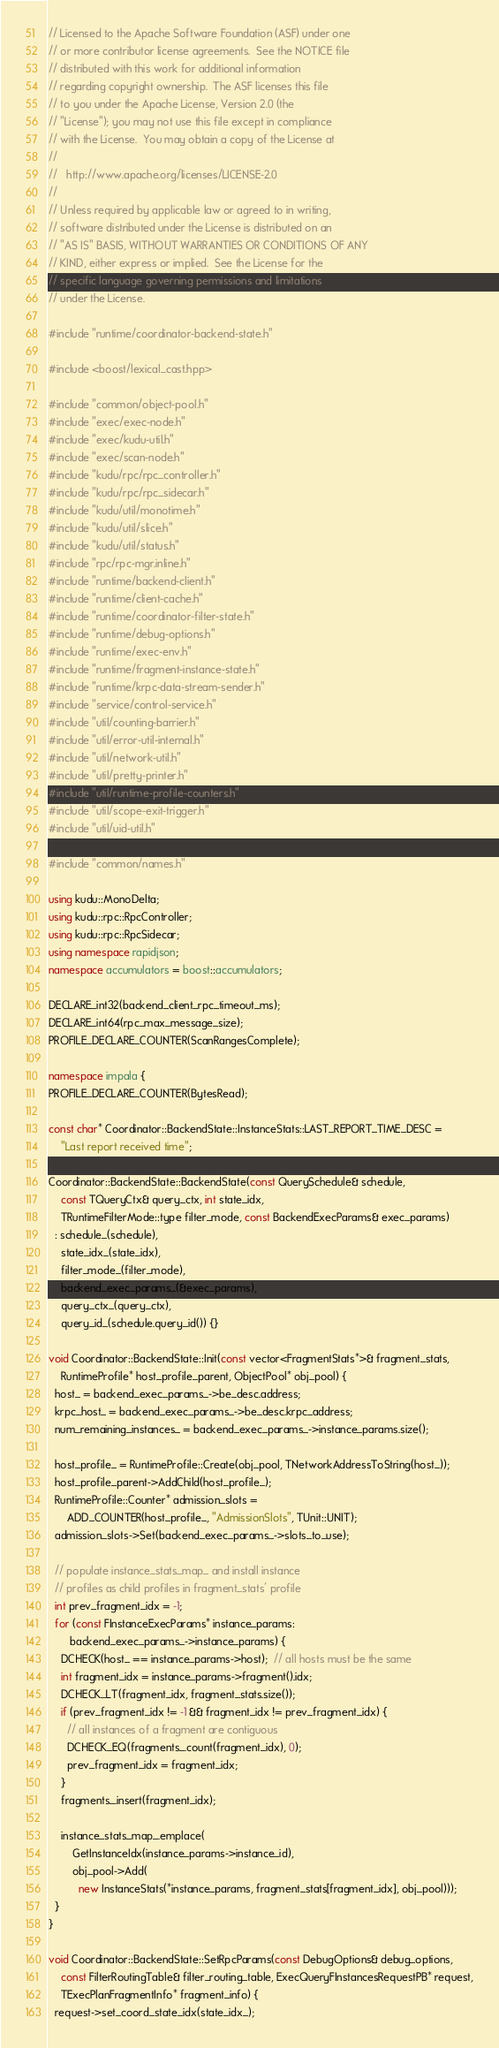Convert code to text. <code><loc_0><loc_0><loc_500><loc_500><_C++_>// Licensed to the Apache Software Foundation (ASF) under one
// or more contributor license agreements.  See the NOTICE file
// distributed with this work for additional information
// regarding copyright ownership.  The ASF licenses this file
// to you under the Apache License, Version 2.0 (the
// "License"); you may not use this file except in compliance
// with the License.  You may obtain a copy of the License at
//
//   http://www.apache.org/licenses/LICENSE-2.0
//
// Unless required by applicable law or agreed to in writing,
// software distributed under the License is distributed on an
// "AS IS" BASIS, WITHOUT WARRANTIES OR CONDITIONS OF ANY
// KIND, either express or implied.  See the License for the
// specific language governing permissions and limitations
// under the License.

#include "runtime/coordinator-backend-state.h"

#include <boost/lexical_cast.hpp>

#include "common/object-pool.h"
#include "exec/exec-node.h"
#include "exec/kudu-util.h"
#include "exec/scan-node.h"
#include "kudu/rpc/rpc_controller.h"
#include "kudu/rpc/rpc_sidecar.h"
#include "kudu/util/monotime.h"
#include "kudu/util/slice.h"
#include "kudu/util/status.h"
#include "rpc/rpc-mgr.inline.h"
#include "runtime/backend-client.h"
#include "runtime/client-cache.h"
#include "runtime/coordinator-filter-state.h"
#include "runtime/debug-options.h"
#include "runtime/exec-env.h"
#include "runtime/fragment-instance-state.h"
#include "runtime/krpc-data-stream-sender.h"
#include "service/control-service.h"
#include "util/counting-barrier.h"
#include "util/error-util-internal.h"
#include "util/network-util.h"
#include "util/pretty-printer.h"
#include "util/runtime-profile-counters.h"
#include "util/scope-exit-trigger.h"
#include "util/uid-util.h"

#include "common/names.h"

using kudu::MonoDelta;
using kudu::rpc::RpcController;
using kudu::rpc::RpcSidecar;
using namespace rapidjson;
namespace accumulators = boost::accumulators;

DECLARE_int32(backend_client_rpc_timeout_ms);
DECLARE_int64(rpc_max_message_size);
PROFILE_DECLARE_COUNTER(ScanRangesComplete);

namespace impala {
PROFILE_DECLARE_COUNTER(BytesRead);

const char* Coordinator::BackendState::InstanceStats::LAST_REPORT_TIME_DESC =
    "Last report received time";

Coordinator::BackendState::BackendState(const QuerySchedule& schedule,
    const TQueryCtx& query_ctx, int state_idx,
    TRuntimeFilterMode::type filter_mode, const BackendExecParams& exec_params)
  : schedule_(schedule),
    state_idx_(state_idx),
    filter_mode_(filter_mode),
    backend_exec_params_(&exec_params),
    query_ctx_(query_ctx),
    query_id_(schedule.query_id()) {}

void Coordinator::BackendState::Init(const vector<FragmentStats*>& fragment_stats,
    RuntimeProfile* host_profile_parent, ObjectPool* obj_pool) {
  host_ = backend_exec_params_->be_desc.address;
  krpc_host_ = backend_exec_params_->be_desc.krpc_address;
  num_remaining_instances_ = backend_exec_params_->instance_params.size();

  host_profile_ = RuntimeProfile::Create(obj_pool, TNetworkAddressToString(host_));
  host_profile_parent->AddChild(host_profile_);
  RuntimeProfile::Counter* admission_slots =
      ADD_COUNTER(host_profile_, "AdmissionSlots", TUnit::UNIT);
  admission_slots->Set(backend_exec_params_->slots_to_use);

  // populate instance_stats_map_ and install instance
  // profiles as child profiles in fragment_stats' profile
  int prev_fragment_idx = -1;
  for (const FInstanceExecParams* instance_params:
       backend_exec_params_->instance_params) {
    DCHECK(host_ == instance_params->host);  // all hosts must be the same
    int fragment_idx = instance_params->fragment().idx;
    DCHECK_LT(fragment_idx, fragment_stats.size());
    if (prev_fragment_idx != -1 && fragment_idx != prev_fragment_idx) {
      // all instances of a fragment are contiguous
      DCHECK_EQ(fragments_.count(fragment_idx), 0);
      prev_fragment_idx = fragment_idx;
    }
    fragments_.insert(fragment_idx);

    instance_stats_map_.emplace(
        GetInstanceIdx(instance_params->instance_id),
        obj_pool->Add(
          new InstanceStats(*instance_params, fragment_stats[fragment_idx], obj_pool)));
  }
}

void Coordinator::BackendState::SetRpcParams(const DebugOptions& debug_options,
    const FilterRoutingTable& filter_routing_table, ExecQueryFInstancesRequestPB* request,
    TExecPlanFragmentInfo* fragment_info) {
  request->set_coord_state_idx(state_idx_);</code> 